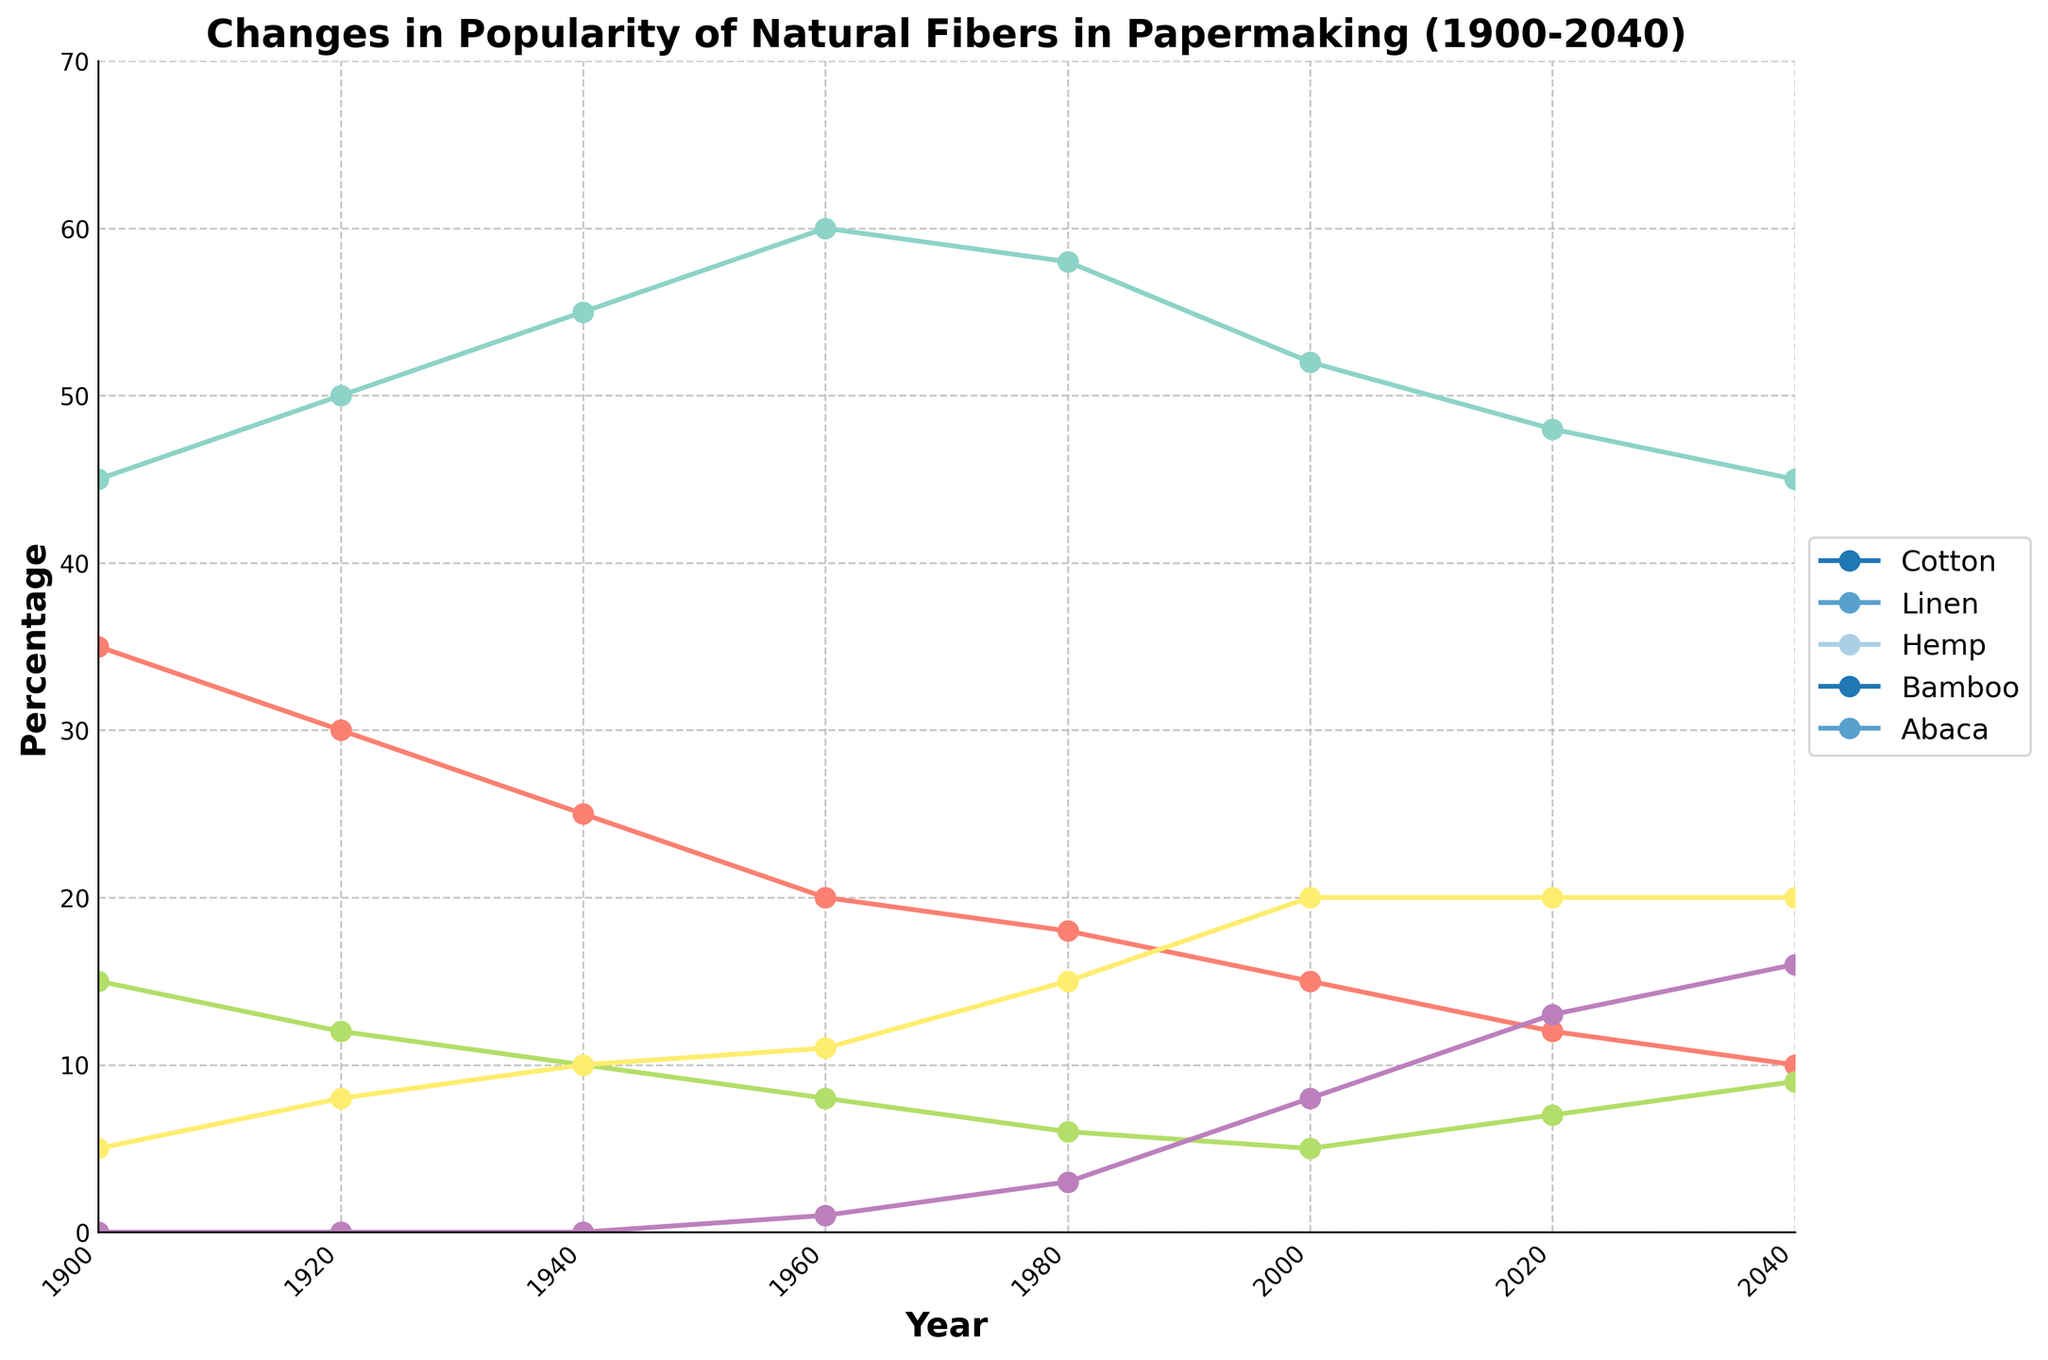What is the percentage change of Cotton from 1900 to 2020? The percentage of Cotton in 1900 is 45%. In 2020, it is 48%. The percentage change is calculated as (48 - 45) / 45 * 100%.
Answer: 6.67% Which fiber showed the greatest increase in popularity from 1900 to 2040? To find this, we compare the initial and final percentages for all fibers. Cotton: (45 to 45), Linen: (35 to 10), Hemp: (15 to 9), Bamboo: (0 to 16), Abaca: (5 to 20). Bamboo increased the most, from 0 to 16%.
Answer: Bamboo Between 1940 and 2000, which fiber's popularity decreased the most? Cotton: (55 to 52), Linen: (25 to 15), Hemp: (10 to 5), Bamboo: (0 to 8), Abaca: (10 to 20). Linen decreased the most, from 25% to 15%.
Answer: Linen What is the average percentage of Abaca from 1900 to 2040? The percentages for Abaca are 5, 8, 10, 11, 15, 20, 20, and 20. Sum them up (5+8+10+11+15+20+20+20 = 109) and divide by the number of data points (8).
Answer: 13.625% In which year did Cotton have the highest percentage, and what was that percentage? By examining the Cotton line across the years, the highest percentage was 60% in 1960.
Answer: 1960, 60% Compare the trend of Hemp and Bamboo from 1980 to 2040. Which is growing faster? Hemp increased from 6% to 9%. Bamboo increased from 3% to 16%. Bamboo grew faster, as its increase (13%) is greater than that of Hemp (3%).
Answer: Bamboo In the year 1940, what was the total percentage for all the fibers combined? Sum of percentages for 1940: Cotton (55) + Linen (25) + Hemp (10) + Bamboo (0) + Abaca (10). 55 + 25 + 10 + 0 + 10 = 100.
Answer: 100% Are any fibers decreasing in popularity from 1980 to 2040? If so, which ones? By comparing 1980 to 2040: Cotton (58 to 45), Linen (18 to 10). Both Cotton and Linen show a decrease.
Answer: Cotton and Linen What is the difference in the percentage of Linen from its peak to the year 2040? Linen's peak percentage is 35% in 1900. In 2040, it is 10%. The difference is 35 - 10.
Answer: 25 Between 2000 and 2040, which fiber shows the least change in percentage? The changes are: Cotton (52 to 45), Linen (15 to 10), Hemp (5 to 9), Bamboo (8 to 16), Abaca (20 to 20). Abaca shows no change.
Answer: Abaca 